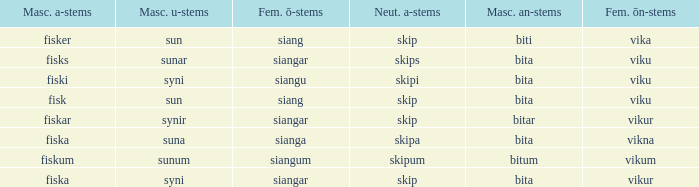What is the masculine u form for the old Swedish word with a neuter a form of skipum? Sunum. 